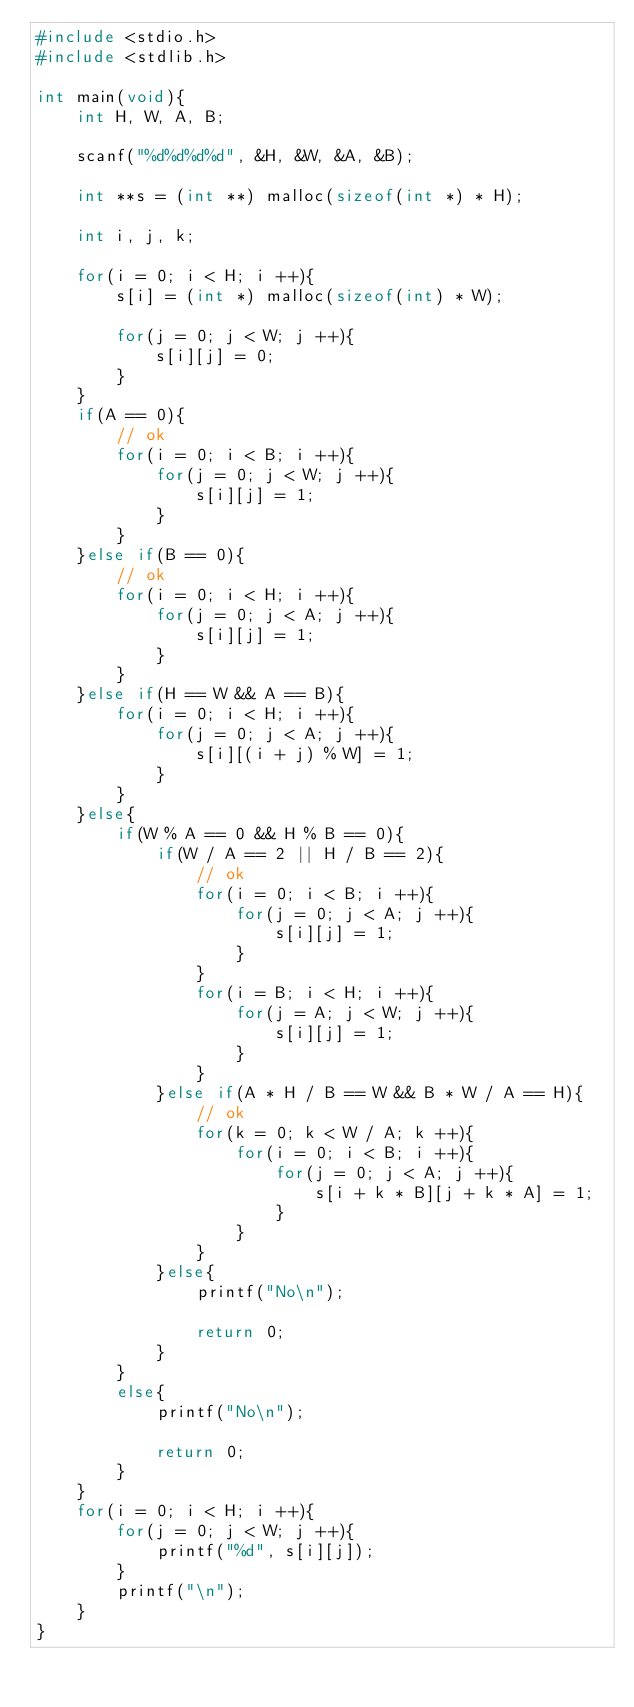<code> <loc_0><loc_0><loc_500><loc_500><_C++_>#include <stdio.h>
#include <stdlib.h>

int main(void){
    int H, W, A, B;

    scanf("%d%d%d%d", &H, &W, &A, &B);

    int **s = (int **) malloc(sizeof(int *) * H);

    int i, j, k;

    for(i = 0; i < H; i ++){
        s[i] = (int *) malloc(sizeof(int) * W);

        for(j = 0; j < W; j ++){
            s[i][j] = 0;
        }
    }
    if(A == 0){
        // ok
        for(i = 0; i < B; i ++){
            for(j = 0; j < W; j ++){
                s[i][j] = 1;
            }
        }
    }else if(B == 0){
        // ok
        for(i = 0; i < H; i ++){
            for(j = 0; j < A; j ++){
                s[i][j] = 1;
            }
        }
    }else if(H == W && A == B){
        for(i = 0; i < H; i ++){
            for(j = 0; j < A; j ++){
                s[i][(i + j) % W] = 1;
            }
        }
    }else{
        if(W % A == 0 && H % B == 0){
            if(W / A == 2 || H / B == 2){
                // ok
                for(i = 0; i < B; i ++){
                    for(j = 0; j < A; j ++){
                        s[i][j] = 1;
                    }
                }
                for(i = B; i < H; i ++){
                    for(j = A; j < W; j ++){
                        s[i][j] = 1;
                    }
                }
            }else if(A * H / B == W && B * W / A == H){
                // ok
                for(k = 0; k < W / A; k ++){
                    for(i = 0; i < B; i ++){
                        for(j = 0; j < A; j ++){
                            s[i + k * B][j + k * A] = 1;
                        }
                    }
                }
            }else{
                printf("No\n");

                return 0;
            }
        }
        else{
            printf("No\n");

            return 0;
        }
    }
    for(i = 0; i < H; i ++){
        for(j = 0; j < W; j ++){
            printf("%d", s[i][j]);
        }
        printf("\n");
    }
}</code> 